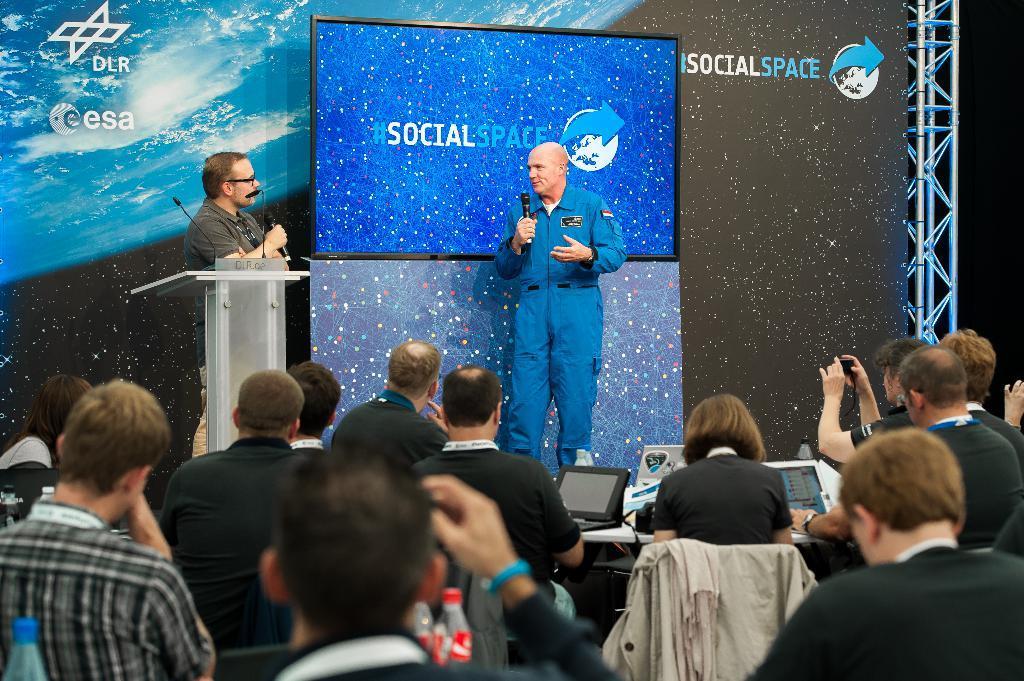How would you summarize this image in a sentence or two? In this image I can see a person wearing blue dress is standing and holding a microphone in his hand and another person wearing black t shirt is standing in front of a podium and holding a microphone. I can see few other persons are standing and few of them are holding cameras in their hands and I can see a table and on it I can see few monitors. In the background I can see a screen, a banner and few metal rods. 